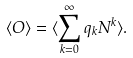<formula> <loc_0><loc_0><loc_500><loc_500>\langle O \rangle = \langle \sum _ { k = 0 } ^ { \infty } q _ { k } N ^ { k } \rangle .</formula> 